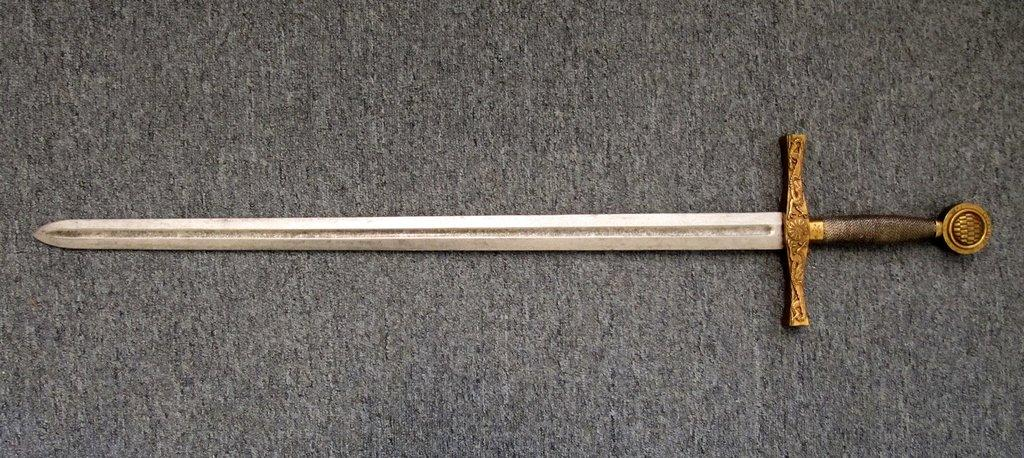What object is on the floor in the image? There is a sword on the floor in the image. Can you describe the sword in more detail? Unfortunately, the facts provided do not give any additional details about the sword. How does the sword turn into a pear in the image? The sword does not turn into a pear in the image, as there is no pear present. 